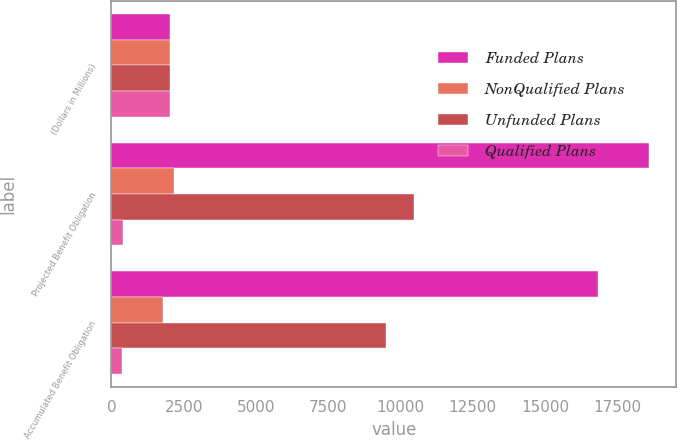<chart> <loc_0><loc_0><loc_500><loc_500><stacked_bar_chart><ecel><fcel>(Dollars in Millions)<fcel>Projected Benefit Obligation<fcel>Accumulated Benefit Obligation<nl><fcel>Funded Plans<fcel>2018<fcel>18609<fcel>16851<nl><fcel>NonQualified Plans<fcel>2018<fcel>2176<fcel>1793<nl><fcel>Unfunded Plans<fcel>2018<fcel>10467<fcel>9510<nl><fcel>Qualified Plans<fcel>2018<fcel>418<fcel>379<nl></chart> 